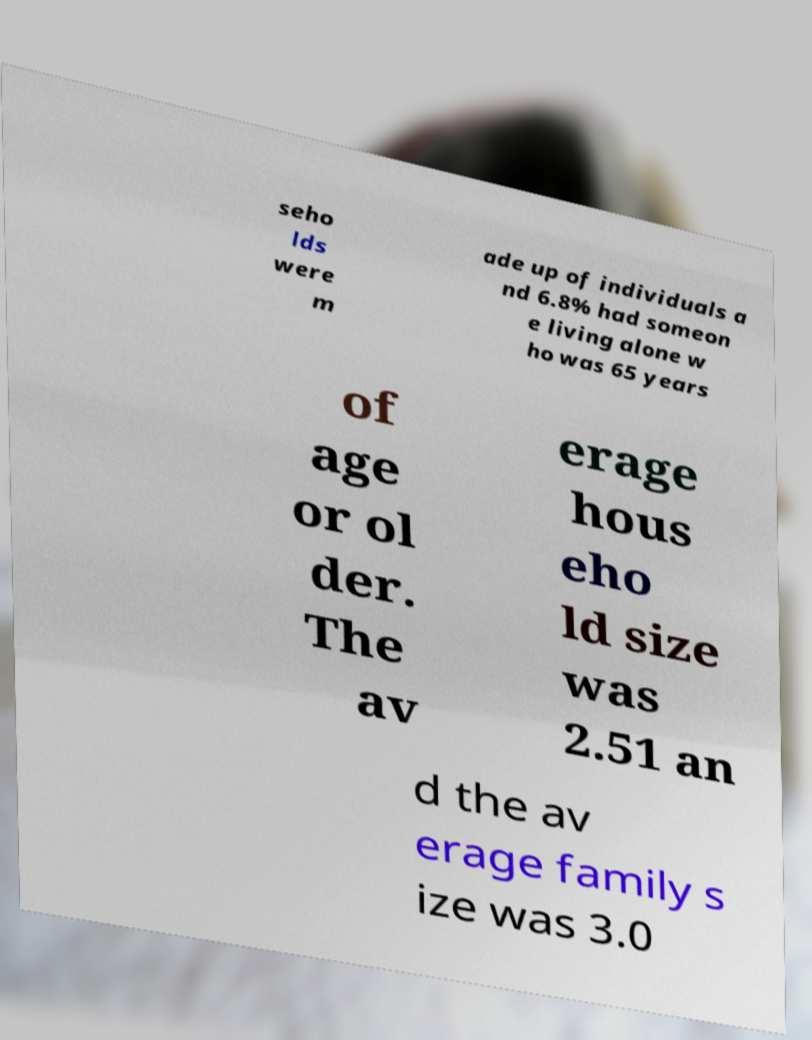I need the written content from this picture converted into text. Can you do that? seho lds were m ade up of individuals a nd 6.8% had someon e living alone w ho was 65 years of age or ol der. The av erage hous eho ld size was 2.51 an d the av erage family s ize was 3.0 